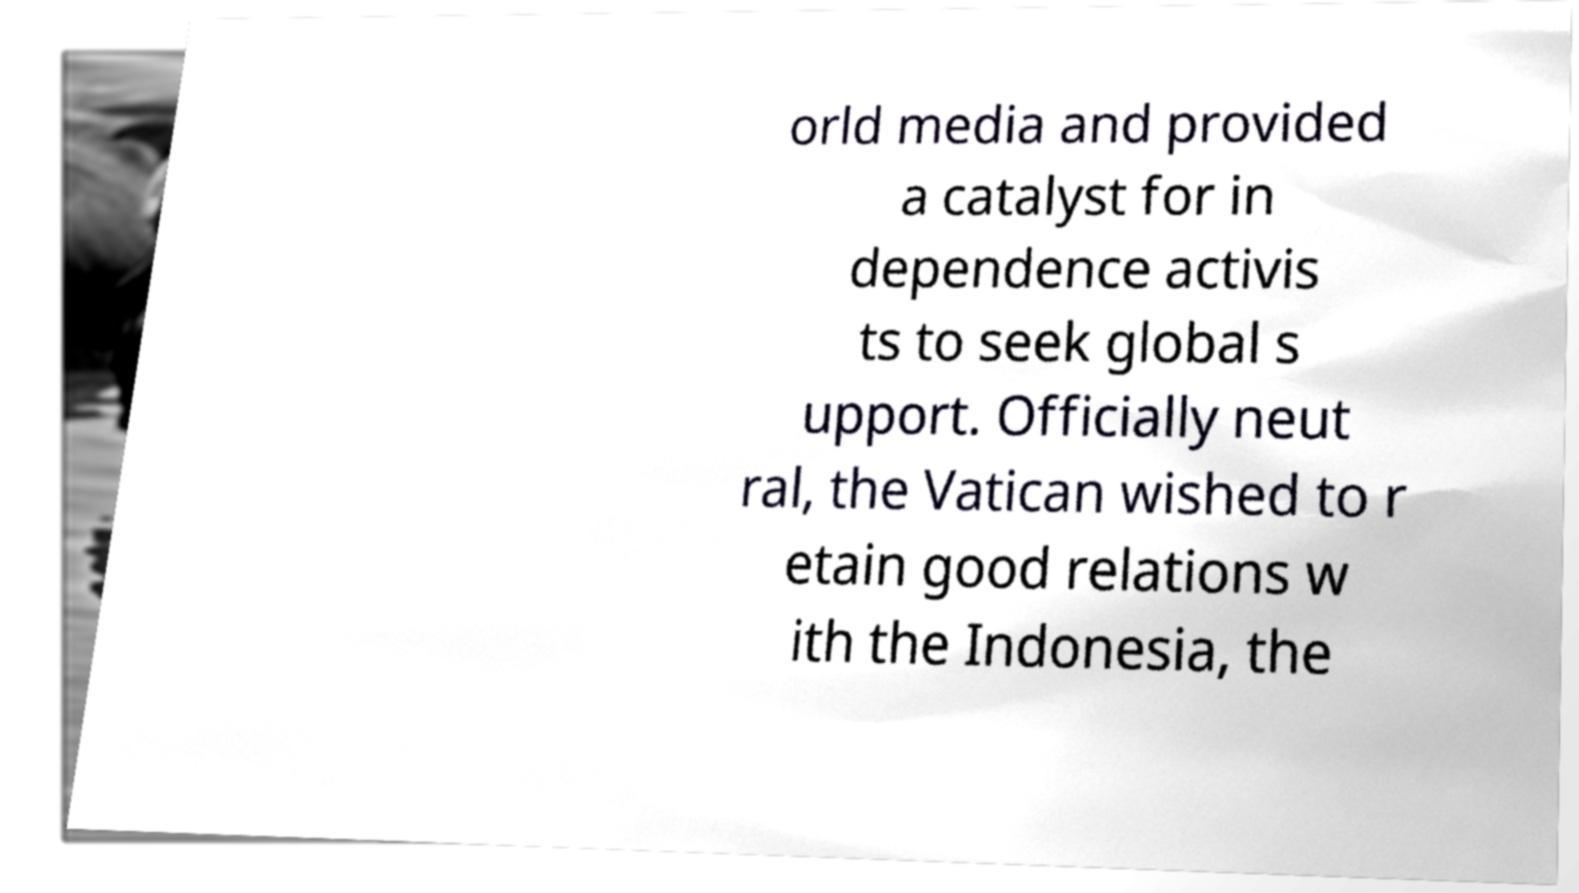For documentation purposes, I need the text within this image transcribed. Could you provide that? orld media and provided a catalyst for in dependence activis ts to seek global s upport. Officially neut ral, the Vatican wished to r etain good relations w ith the Indonesia, the 